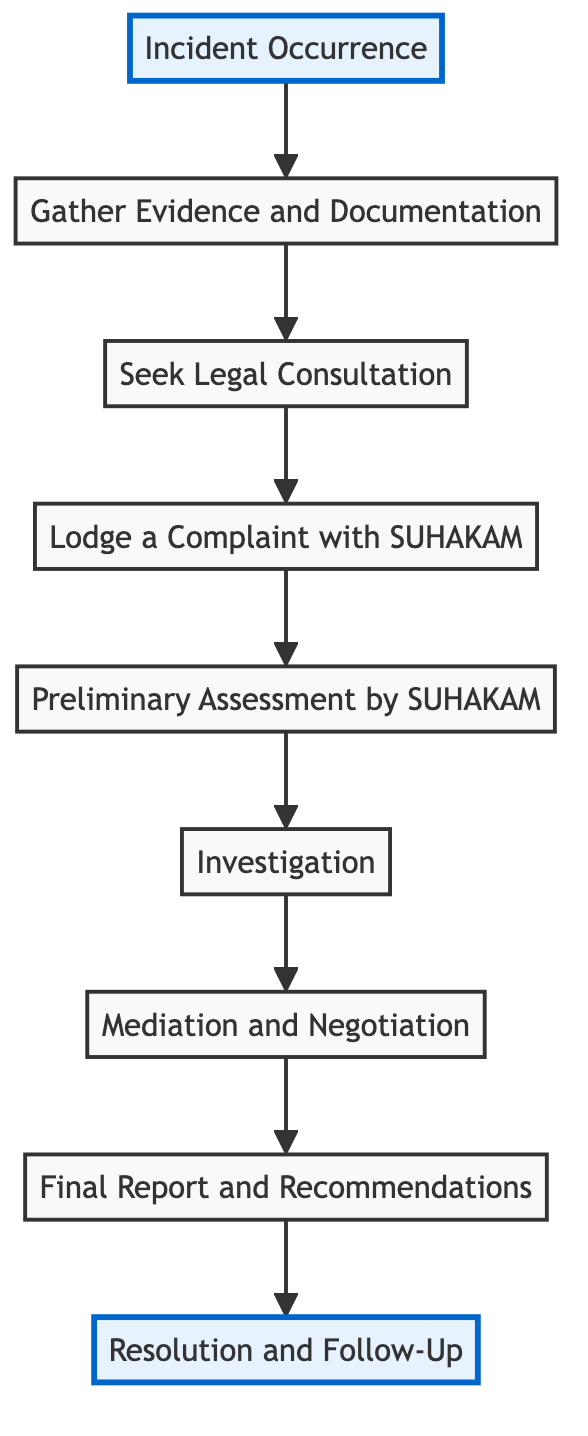What's the first step in the process? The first step, as represented at the bottom of the diagram, is "Incident Occurrence." This indicates that any human rights complaint process begins with an incident that violates a person's rights.
Answer: Incident Occurrence How many nodes are in the diagram? The diagram contains a total of 9 nodes, starting from "Incident Occurrence" and ending with "Resolution and Follow-Up." Each node represents a distinct step in the complaint process.
Answer: 9 What comes after "Gather Evidence and Documentation"? Once "Gather Evidence and Documentation" is completed, the next step in the process is "Seek Legal Consultation," indicating that after gathering evidence, the individual should consult a legal expert.
Answer: Seek Legal Consultation What is the last step in the process? The final step, located at the top of the diagram, is "Resolution and Follow-Up," which signifies that after the final report is issued, the relevant parties take corrective actions and SUHAKAM checks for compliance.
Answer: Resolution and Follow-Up Which step follows "Investigation"? The step that follows "Investigation" is "Mediation and Negotiation." This shows that after the investigation, SUHAKAM may attempt to mediate between the parties involved.
Answer: Mediation and Negotiation What are the first three steps in the process? The first three steps, moving from the bottom to the top of the diagram, are "Incident Occurrence," "Gather Evidence and Documentation," and "Seek Legal Consultation." These steps must be completed before lodging a complaint.
Answer: Incident Occurrence, Gather Evidence and Documentation, Seek Legal Consultation What is the relationship between "Preliminary Assessment by SUHAKAM" and "Investigation"? The relationship indicated in the diagram shows that "Preliminary Assessment by SUHAKAM" precedes "Investigation." This implies that the preliminary assessment must occur to determine if an investigation is warranted.
Answer: Precedes What happens if mediation is successful? If mediation is successful, it would likely lead to a "Final Report and Recommendations" where SUHAKAM summarizes the outcome and provides corrective actions based on the mediation results.
Answer: Final Report and Recommendations What is the purpose of the "Final Report and Recommendations"? The purpose is to summarize findings from the investigation and mediation processes, providing recommendations for any necessary corrective actions to resolve the human rights complaint.
Answer: Summarize findings and recommend corrective actions 